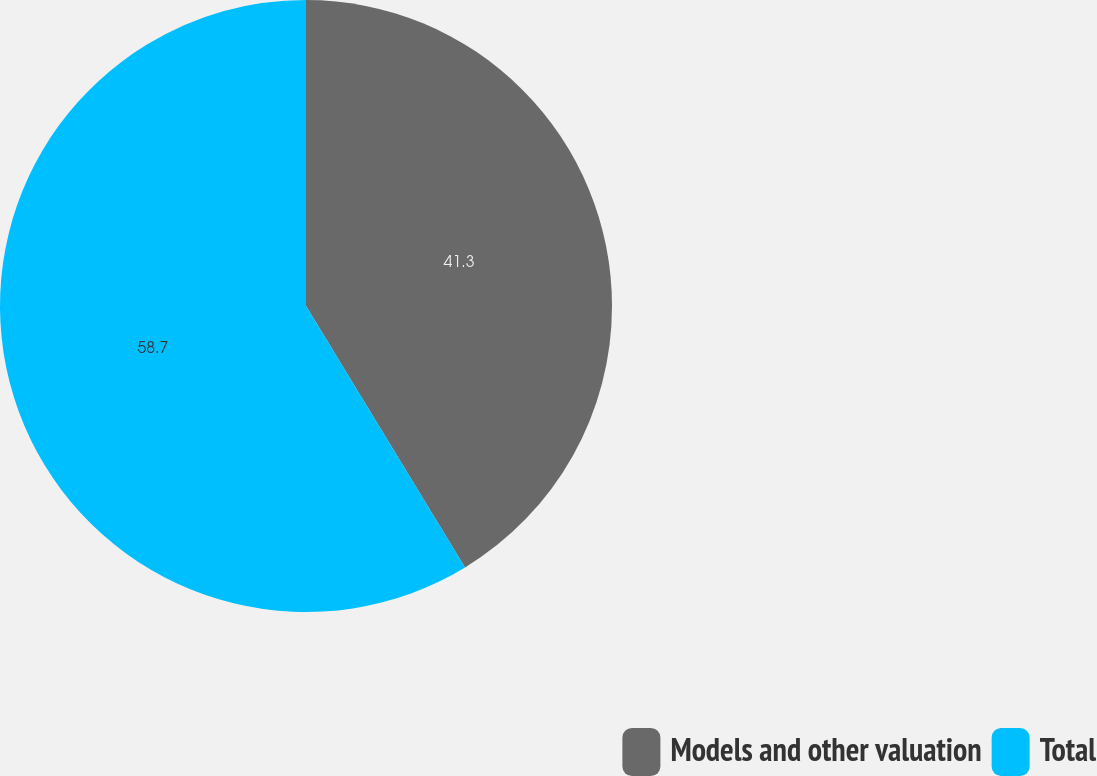Convert chart to OTSL. <chart><loc_0><loc_0><loc_500><loc_500><pie_chart><fcel>Models and other valuation<fcel>Total<nl><fcel>41.3%<fcel>58.7%<nl></chart> 